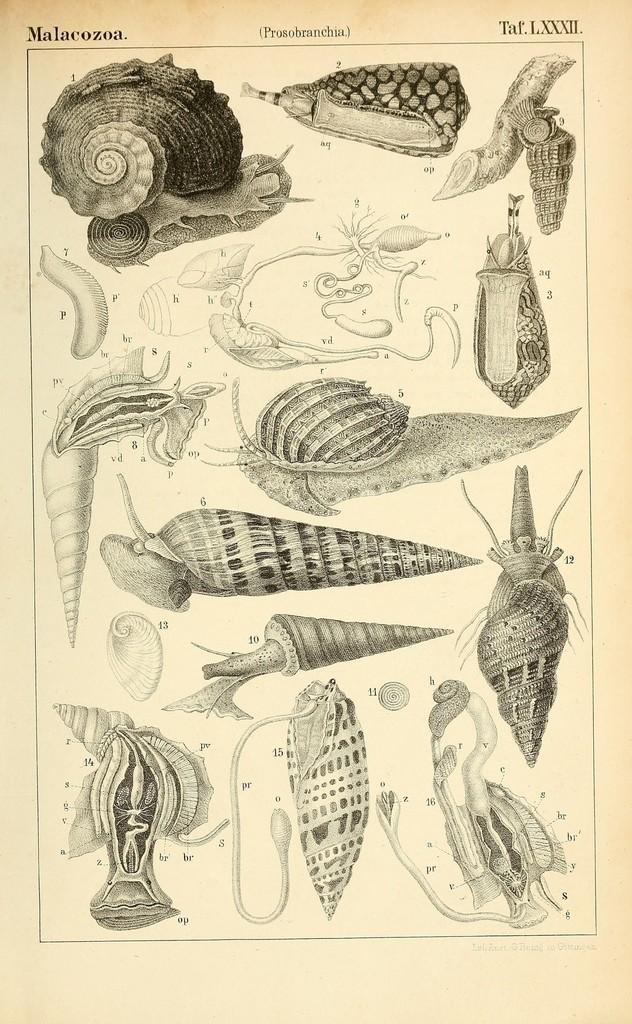Describe this image in one or two sentences. In the picture I can see an art of different kind of sea shells with labeling and on the top of the image we can see some watermarks. 